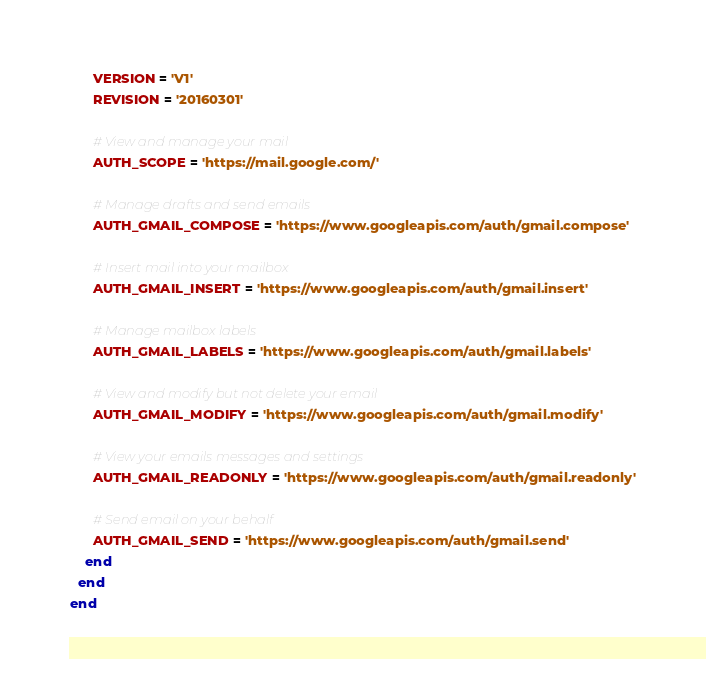Convert code to text. <code><loc_0><loc_0><loc_500><loc_500><_Ruby_>      VERSION = 'V1'
      REVISION = '20160301'

      # View and manage your mail
      AUTH_SCOPE = 'https://mail.google.com/'

      # Manage drafts and send emails
      AUTH_GMAIL_COMPOSE = 'https://www.googleapis.com/auth/gmail.compose'

      # Insert mail into your mailbox
      AUTH_GMAIL_INSERT = 'https://www.googleapis.com/auth/gmail.insert'

      # Manage mailbox labels
      AUTH_GMAIL_LABELS = 'https://www.googleapis.com/auth/gmail.labels'

      # View and modify but not delete your email
      AUTH_GMAIL_MODIFY = 'https://www.googleapis.com/auth/gmail.modify'

      # View your emails messages and settings
      AUTH_GMAIL_READONLY = 'https://www.googleapis.com/auth/gmail.readonly'

      # Send email on your behalf
      AUTH_GMAIL_SEND = 'https://www.googleapis.com/auth/gmail.send'
    end
  end
end
</code> 